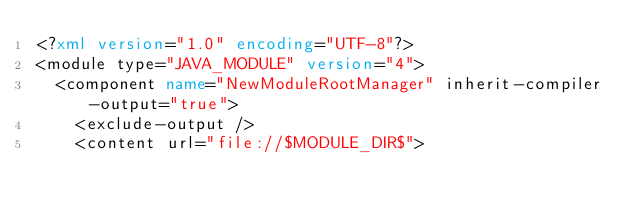Convert code to text. <code><loc_0><loc_0><loc_500><loc_500><_XML_><?xml version="1.0" encoding="UTF-8"?>
<module type="JAVA_MODULE" version="4">
  <component name="NewModuleRootManager" inherit-compiler-output="true">
    <exclude-output />
    <content url="file://$MODULE_DIR$"></code> 